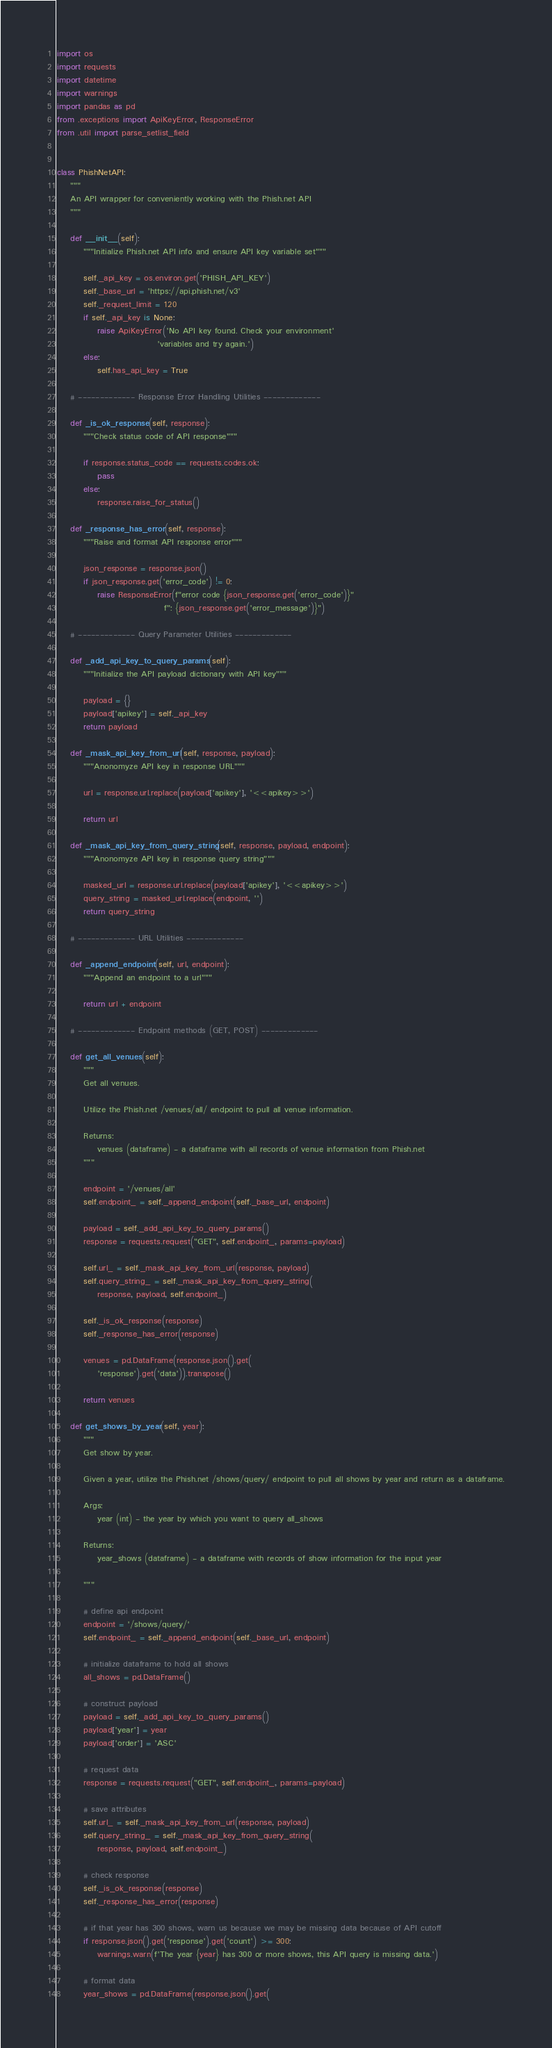<code> <loc_0><loc_0><loc_500><loc_500><_Python_>import os
import requests
import datetime
import warnings
import pandas as pd
from .exceptions import ApiKeyError, ResponseError
from .util import parse_setlist_field


class PhishNetAPI:
    """
    An API wrapper for conveniently working with the Phish.net API
    """

    def __init__(self):
        """Initialize Phish.net API info and ensure API key variable set"""

        self._api_key = os.environ.get('PHISH_API_KEY')
        self._base_url = 'https://api.phish.net/v3'
        self._request_limit = 120
        if self._api_key is None:
            raise ApiKeyError('No API key found. Check your environment'
                              'variables and try again.')
        else:
            self.has_api_key = True

    # ------------- Response Error Handling Utilities -------------

    def _is_ok_response(self, response):
        """Check status code of API response"""

        if response.status_code == requests.codes.ok:
            pass
        else:
            response.raise_for_status()

    def _response_has_error(self, response):
        """Raise and format API response error"""

        json_response = response.json()
        if json_response.get('error_code') != 0:
            raise ResponseError(f"error code {json_response.get('error_code')}"
                                f": {json_response.get('error_message')}")

    # ------------- Query Parameter Utilities -------------

    def _add_api_key_to_query_params(self):
        """Initialize the API payload dictionary with API key"""

        payload = {}
        payload['apikey'] = self._api_key
        return payload

    def _mask_api_key_from_url(self, response, payload):
        """Anonomyze API key in response URL"""

        url = response.url.replace(payload['apikey'], '<<apikey>>')

        return url

    def _mask_api_key_from_query_string(self, response, payload, endpoint):
        """Anonomyze API key in response query string"""

        masked_url = response.url.replace(payload['apikey'], '<<apikey>>')
        query_string = masked_url.replace(endpoint, '')
        return query_string

    # ------------- URL Utilities -------------

    def _append_endpoint(self, url, endpoint):
        """Append an endpoint to a url"""

        return url + endpoint

    # ------------- Endpoint methods (GET, POST) -------------

    def get_all_venues(self):
        """
        Get all venues.

        Utilize the Phish.net /venues/all/ endpoint to pull all venue information.

        Returns:
            venues (dataframe) - a dataframe with all records of venue information from Phish.net
        """

        endpoint = '/venues/all'
        self.endpoint_ = self._append_endpoint(self._base_url, endpoint)

        payload = self._add_api_key_to_query_params()
        response = requests.request("GET", self.endpoint_, params=payload)

        self.url_ = self._mask_api_key_from_url(response, payload)
        self.query_string_ = self._mask_api_key_from_query_string(
            response, payload, self.endpoint_)

        self._is_ok_response(response)
        self._response_has_error(response)

        venues = pd.DataFrame(response.json().get(
            'response').get('data')).transpose()

        return venues

    def get_shows_by_year(self, year):
        """
        Get show by year.

        Given a year, utilize the Phish.net /shows/query/ endpoint to pull all shows by year and return as a dataframe.

        Args:
            year (int) - the year by which you want to query all_shows

        Returns:
            year_shows (dataframe) - a dataframe with records of show information for the input year

        """

        # define api endpoint
        endpoint = '/shows/query/'
        self.endpoint_ = self._append_endpoint(self._base_url, endpoint)

        # initialize dataframe to hold all shows
        all_shows = pd.DataFrame()

        # construct payload
        payload = self._add_api_key_to_query_params()
        payload['year'] = year
        payload['order'] = 'ASC'

        # request data
        response = requests.request("GET", self.endpoint_, params=payload)

        # save attributes
        self.url_ = self._mask_api_key_from_url(response, payload)
        self.query_string_ = self._mask_api_key_from_query_string(
            response, payload, self.endpoint_)

        # check response
        self._is_ok_response(response)
        self._response_has_error(response)

        # if that year has 300 shows, warn us because we may be missing data because of API cutoff
        if response.json().get('response').get('count') >= 300:
            warnings.warn(f'The year {year} has 300 or more shows, this API query is missing data.')

        # format data
        year_shows = pd.DataFrame(response.json().get(</code> 